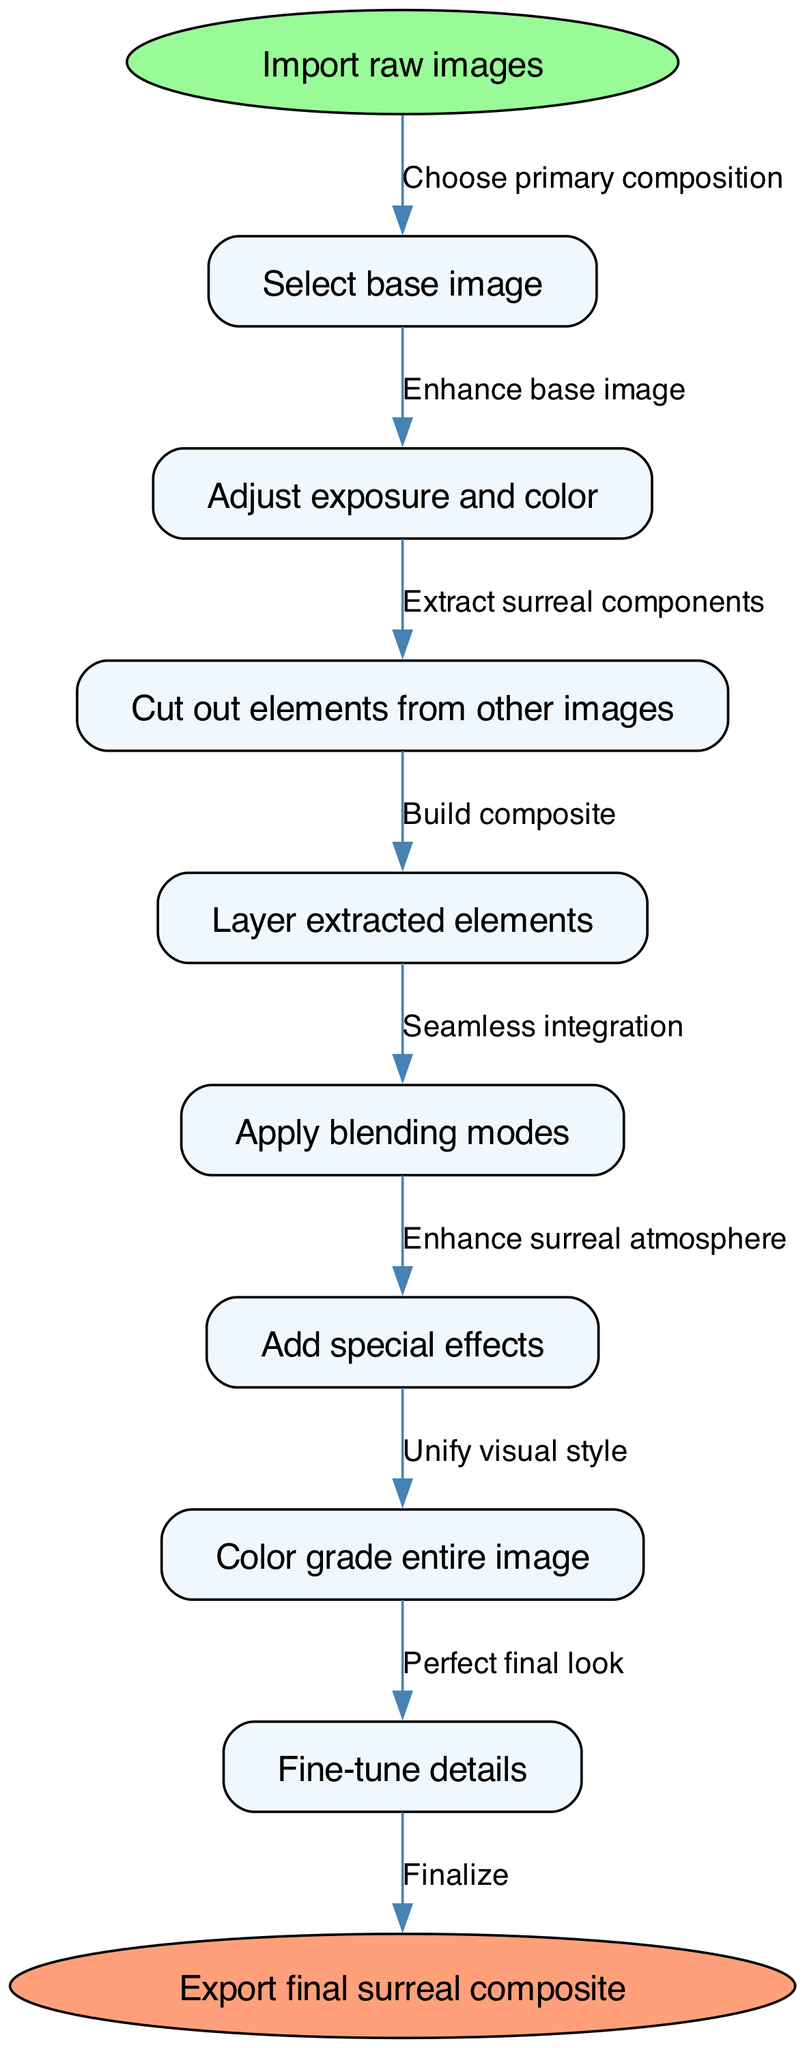What is the base action in the workflow? The workflow begins with the action of "Import raw images". This is the starting point indicated clearly at the top of the flowchart.
Answer: Import raw images How many steps are there in the workflow? There are a total of 8 steps listed in the workflow between the start and end nodes, each detailing a specific action to achieve the final output.
Answer: 8 What node comes after "Adjust exposure and color"? The next node after "Adjust exposure and color" is "Cut out elements from other images". This can be determined by following the arrow from the exposure and color adjustment node to the subsequent action.
Answer: Cut out elements from other images What is the last action before exporting? The last action before exporting is "Fine-tune details". This step directly precedes the final node that represents the export of the composite image.
Answer: Fine-tune details Which nodes are directly related to enhancing the visual impact of the image? The nodes related to enhancing the visual impact of the image are "Adjust exposure and color", "Add special effects", and "Color grade entire image". These nodes focus on altering aesthetics and visual appeal.
Answer: Adjust exposure and color, Add special effects, Color grade entire image What is the purpose of applying blending modes in the workflow? The purpose of applying blending modes is to ensure "Seamless integration" of the different layers within the composite image. This step is crucial for merging various elements effectively.
Answer: Seamless integration Which step is the first to deal with elements extracted from other images? The first step that deals with elements extracted from other images is "Cut out elements from other images". This reflects the process of preparing to merge additional components into the base image.
Answer: Cut out elements from other images What type of node is at the start of the diagram? The start of the diagram features an "ellipse" shaped node, which is used to denote the initial action or entry point into the workflow.
Answer: ellipse 